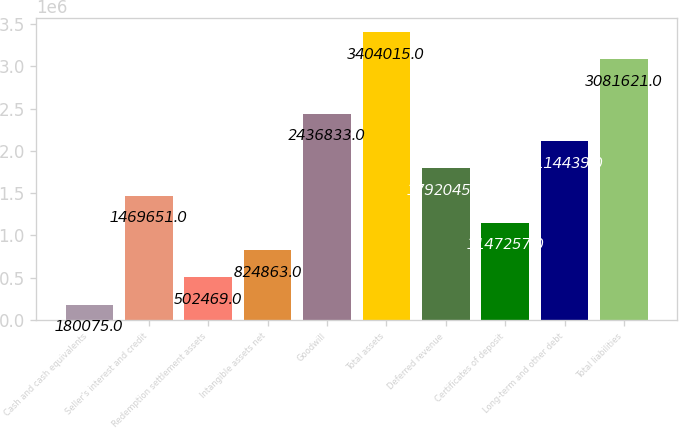Convert chart. <chart><loc_0><loc_0><loc_500><loc_500><bar_chart><fcel>Cash and cash equivalents<fcel>Seller's interest and credit<fcel>Redemption settlement assets<fcel>Intangible assets net<fcel>Goodwill<fcel>Total assets<fcel>Deferred revenue<fcel>Certificates of deposit<fcel>Long-term and other debt<fcel>Total liabilities<nl><fcel>180075<fcel>1.46965e+06<fcel>502469<fcel>824863<fcel>2.43683e+06<fcel>3.40402e+06<fcel>1.79204e+06<fcel>1.14726e+06<fcel>2.11444e+06<fcel>3.08162e+06<nl></chart> 